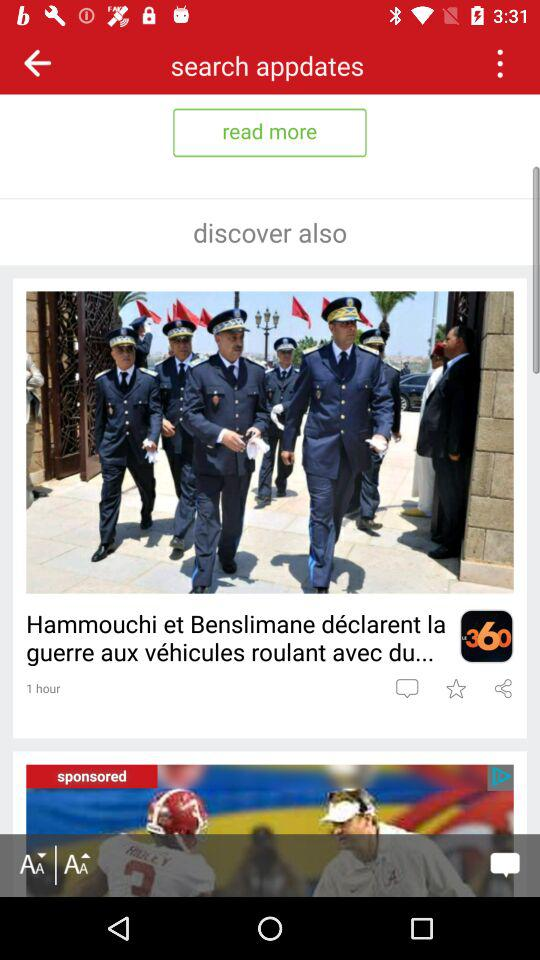When was the article posted? The article was posted 1 hour ago. 